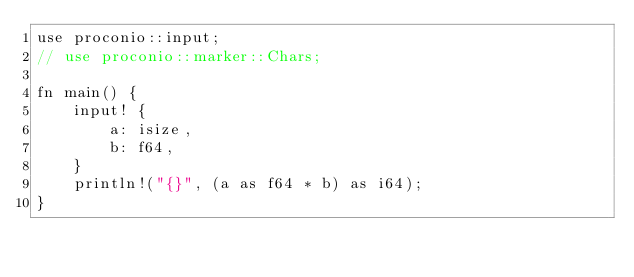<code> <loc_0><loc_0><loc_500><loc_500><_Rust_>use proconio::input;
// use proconio::marker::Chars;

fn main() {
	input! {
		a: isize,
		b: f64,
	}
	println!("{}", (a as f64 * b) as i64);
}
</code> 